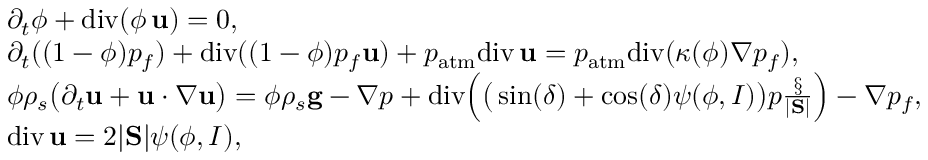Convert formula to latex. <formula><loc_0><loc_0><loc_500><loc_500>\begin{array} { r l } & { \partial _ { t } \phi + d i v ( \phi \, { u } ) = 0 , } \\ & { \partial _ { t } ( ( 1 - \phi ) p _ { f } ) + d i v ( ( 1 - \phi ) p _ { f } { u } ) + p _ { a t m } d i v \, { u } = p _ { a t m } d i v ( \kappa ( \phi ) \nabla p _ { f } ) , } \\ & { \phi \rho _ { s } \left ( \partial _ { t } { u } + { u } \cdot \nabla { u } \right ) = \phi \rho _ { s } { g } - \nabla p + d i v \left ( \left ( \sin ( \delta ) + \cos ( \delta ) \psi ( \phi , I ) \right ) p \frac { \S } { | S | } \right ) - \nabla p _ { f } , } \\ & { d i v \, { u } = 2 | S | \psi ( \phi , I ) , } \end{array}</formula> 